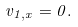<formula> <loc_0><loc_0><loc_500><loc_500>v _ { 1 , x } = 0 .</formula> 